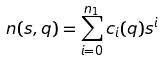Convert formula to latex. <formula><loc_0><loc_0><loc_500><loc_500>n ( s , q ) = \sum _ { i = 0 } ^ { n _ { 1 } } c _ { i } ( q ) s ^ { i }</formula> 